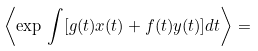<formula> <loc_0><loc_0><loc_500><loc_500>\left \langle \exp \, \int [ g ( t ) x ( t ) + f ( t ) y ( t ) ] d t \right \rangle =</formula> 